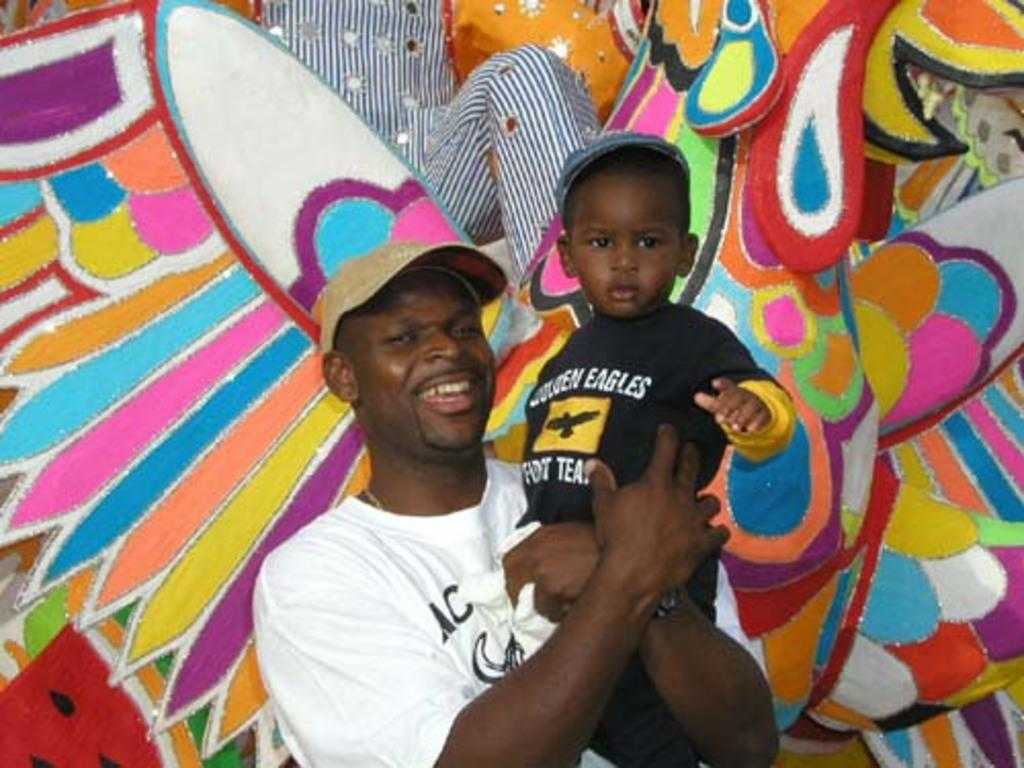<image>
Summarize the visual content of the image. A man posing with a small boy wearing an Eagles tee shirt. 